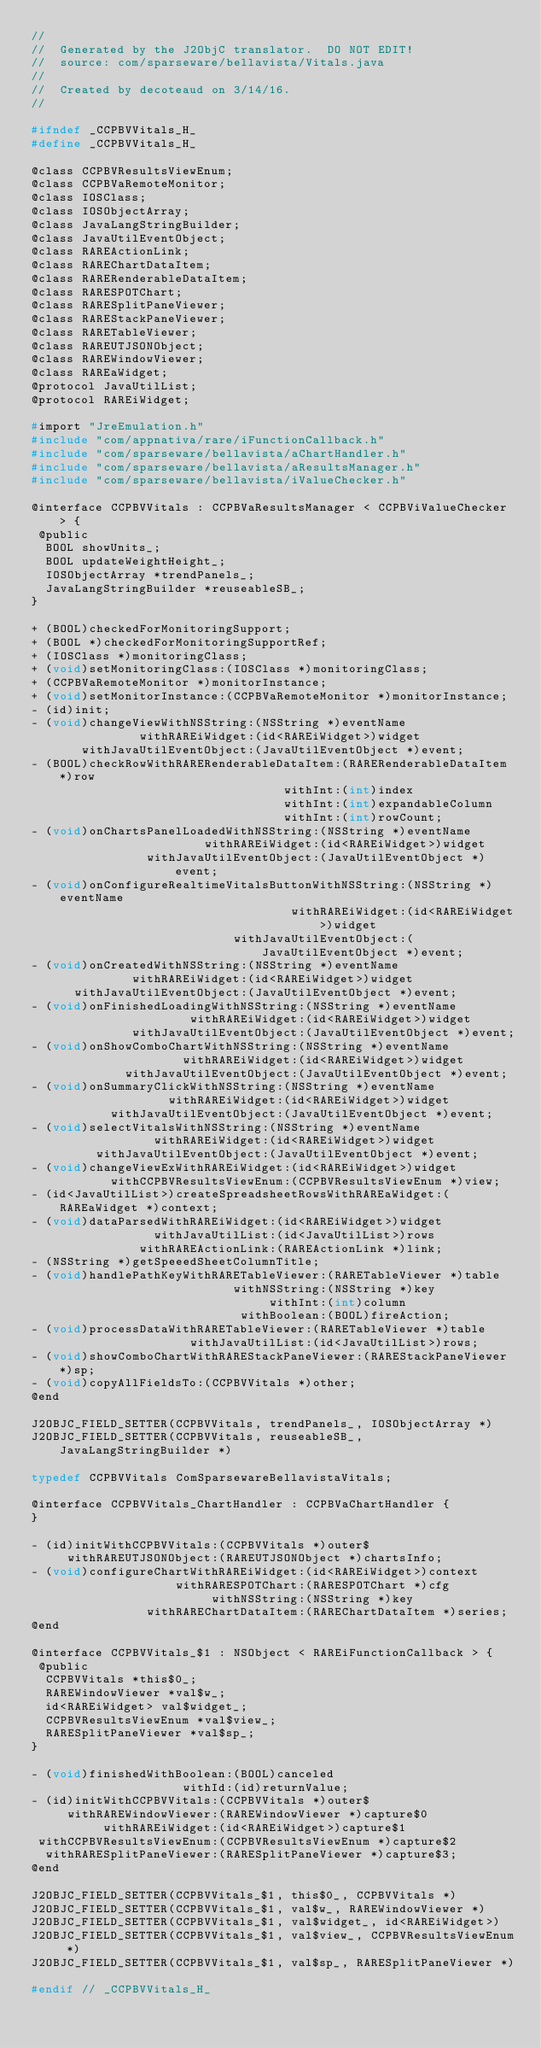Convert code to text. <code><loc_0><loc_0><loc_500><loc_500><_C_>//
//  Generated by the J2ObjC translator.  DO NOT EDIT!
//  source: com/sparseware/bellavista/Vitals.java
//
//  Created by decoteaud on 3/14/16.
//

#ifndef _CCPBVVitals_H_
#define _CCPBVVitals_H_

@class CCPBVResultsViewEnum;
@class CCPBVaRemoteMonitor;
@class IOSClass;
@class IOSObjectArray;
@class JavaLangStringBuilder;
@class JavaUtilEventObject;
@class RAREActionLink;
@class RAREChartDataItem;
@class RARERenderableDataItem;
@class RARESPOTChart;
@class RARESplitPaneViewer;
@class RAREStackPaneViewer;
@class RARETableViewer;
@class RAREUTJSONObject;
@class RAREWindowViewer;
@class RAREaWidget;
@protocol JavaUtilList;
@protocol RAREiWidget;

#import "JreEmulation.h"
#include "com/appnativa/rare/iFunctionCallback.h"
#include "com/sparseware/bellavista/aChartHandler.h"
#include "com/sparseware/bellavista/aResultsManager.h"
#include "com/sparseware/bellavista/iValueChecker.h"

@interface CCPBVVitals : CCPBVaResultsManager < CCPBViValueChecker > {
 @public
  BOOL showUnits_;
  BOOL updateWeightHeight_;
  IOSObjectArray *trendPanels_;
  JavaLangStringBuilder *reuseableSB_;
}

+ (BOOL)checkedForMonitoringSupport;
+ (BOOL *)checkedForMonitoringSupportRef;
+ (IOSClass *)monitoringClass;
+ (void)setMonitoringClass:(IOSClass *)monitoringClass;
+ (CCPBVaRemoteMonitor *)monitorInstance;
+ (void)setMonitorInstance:(CCPBVaRemoteMonitor *)monitorInstance;
- (id)init;
- (void)changeViewWithNSString:(NSString *)eventName
               withRAREiWidget:(id<RAREiWidget>)widget
       withJavaUtilEventObject:(JavaUtilEventObject *)event;
- (BOOL)checkRowWithRARERenderableDataItem:(RARERenderableDataItem *)row
                                   withInt:(int)index
                                   withInt:(int)expandableColumn
                                   withInt:(int)rowCount;
- (void)onChartsPanelLoadedWithNSString:(NSString *)eventName
                        withRAREiWidget:(id<RAREiWidget>)widget
                withJavaUtilEventObject:(JavaUtilEventObject *)event;
- (void)onConfigureRealtimeVitalsButtonWithNSString:(NSString *)eventName
                                    withRAREiWidget:(id<RAREiWidget>)widget
                            withJavaUtilEventObject:(JavaUtilEventObject *)event;
- (void)onCreatedWithNSString:(NSString *)eventName
              withRAREiWidget:(id<RAREiWidget>)widget
      withJavaUtilEventObject:(JavaUtilEventObject *)event;
- (void)onFinishedLoadingWithNSString:(NSString *)eventName
                      withRAREiWidget:(id<RAREiWidget>)widget
              withJavaUtilEventObject:(JavaUtilEventObject *)event;
- (void)onShowComboChartWithNSString:(NSString *)eventName
                     withRAREiWidget:(id<RAREiWidget>)widget
             withJavaUtilEventObject:(JavaUtilEventObject *)event;
- (void)onSummaryClickWithNSString:(NSString *)eventName
                   withRAREiWidget:(id<RAREiWidget>)widget
           withJavaUtilEventObject:(JavaUtilEventObject *)event;
- (void)selectVitalsWithNSString:(NSString *)eventName
                 withRAREiWidget:(id<RAREiWidget>)widget
         withJavaUtilEventObject:(JavaUtilEventObject *)event;
- (void)changeViewExWithRAREiWidget:(id<RAREiWidget>)widget
           withCCPBVResultsViewEnum:(CCPBVResultsViewEnum *)view;
- (id<JavaUtilList>)createSpreadsheetRowsWithRAREaWidget:(RAREaWidget *)context;
- (void)dataParsedWithRAREiWidget:(id<RAREiWidget>)widget
                 withJavaUtilList:(id<JavaUtilList>)rows
               withRAREActionLink:(RAREActionLink *)link;
- (NSString *)getSpeeedSheetColumnTitle;
- (void)handlePathKeyWithRARETableViewer:(RARETableViewer *)table
                            withNSString:(NSString *)key
                                 withInt:(int)column
                             withBoolean:(BOOL)fireAction;
- (void)processDataWithRARETableViewer:(RARETableViewer *)table
                      withJavaUtilList:(id<JavaUtilList>)rows;
- (void)showComboChartWithRAREStackPaneViewer:(RAREStackPaneViewer *)sp;
- (void)copyAllFieldsTo:(CCPBVVitals *)other;
@end

J2OBJC_FIELD_SETTER(CCPBVVitals, trendPanels_, IOSObjectArray *)
J2OBJC_FIELD_SETTER(CCPBVVitals, reuseableSB_, JavaLangStringBuilder *)

typedef CCPBVVitals ComSparsewareBellavistaVitals;

@interface CCPBVVitals_ChartHandler : CCPBVaChartHandler {
}

- (id)initWithCCPBVVitals:(CCPBVVitals *)outer$
     withRAREUTJSONObject:(RAREUTJSONObject *)chartsInfo;
- (void)configureChartWithRAREiWidget:(id<RAREiWidget>)context
                    withRARESPOTChart:(RARESPOTChart *)cfg
                         withNSString:(NSString *)key
                withRAREChartDataItem:(RAREChartDataItem *)series;
@end

@interface CCPBVVitals_$1 : NSObject < RAREiFunctionCallback > {
 @public
  CCPBVVitals *this$0_;
  RAREWindowViewer *val$w_;
  id<RAREiWidget> val$widget_;
  CCPBVResultsViewEnum *val$view_;
  RARESplitPaneViewer *val$sp_;
}

- (void)finishedWithBoolean:(BOOL)canceled
                     withId:(id)returnValue;
- (id)initWithCCPBVVitals:(CCPBVVitals *)outer$
     withRAREWindowViewer:(RAREWindowViewer *)capture$0
          withRAREiWidget:(id<RAREiWidget>)capture$1
 withCCPBVResultsViewEnum:(CCPBVResultsViewEnum *)capture$2
  withRARESplitPaneViewer:(RARESplitPaneViewer *)capture$3;
@end

J2OBJC_FIELD_SETTER(CCPBVVitals_$1, this$0_, CCPBVVitals *)
J2OBJC_FIELD_SETTER(CCPBVVitals_$1, val$w_, RAREWindowViewer *)
J2OBJC_FIELD_SETTER(CCPBVVitals_$1, val$widget_, id<RAREiWidget>)
J2OBJC_FIELD_SETTER(CCPBVVitals_$1, val$view_, CCPBVResultsViewEnum *)
J2OBJC_FIELD_SETTER(CCPBVVitals_$1, val$sp_, RARESplitPaneViewer *)

#endif // _CCPBVVitals_H_
</code> 